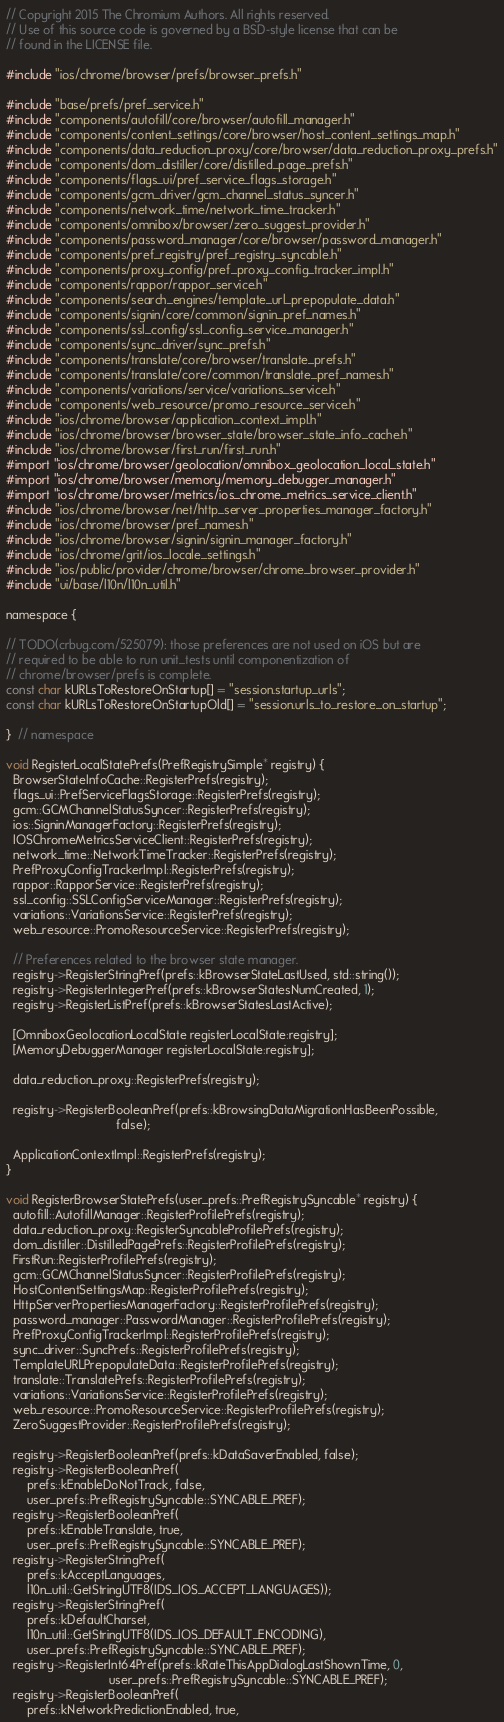Convert code to text. <code><loc_0><loc_0><loc_500><loc_500><_ObjectiveC_>// Copyright 2015 The Chromium Authors. All rights reserved.
// Use of this source code is governed by a BSD-style license that can be
// found in the LICENSE file.

#include "ios/chrome/browser/prefs/browser_prefs.h"

#include "base/prefs/pref_service.h"
#include "components/autofill/core/browser/autofill_manager.h"
#include "components/content_settings/core/browser/host_content_settings_map.h"
#include "components/data_reduction_proxy/core/browser/data_reduction_proxy_prefs.h"
#include "components/dom_distiller/core/distilled_page_prefs.h"
#include "components/flags_ui/pref_service_flags_storage.h"
#include "components/gcm_driver/gcm_channel_status_syncer.h"
#include "components/network_time/network_time_tracker.h"
#include "components/omnibox/browser/zero_suggest_provider.h"
#include "components/password_manager/core/browser/password_manager.h"
#include "components/pref_registry/pref_registry_syncable.h"
#include "components/proxy_config/pref_proxy_config_tracker_impl.h"
#include "components/rappor/rappor_service.h"
#include "components/search_engines/template_url_prepopulate_data.h"
#include "components/signin/core/common/signin_pref_names.h"
#include "components/ssl_config/ssl_config_service_manager.h"
#include "components/sync_driver/sync_prefs.h"
#include "components/translate/core/browser/translate_prefs.h"
#include "components/translate/core/common/translate_pref_names.h"
#include "components/variations/service/variations_service.h"
#include "components/web_resource/promo_resource_service.h"
#include "ios/chrome/browser/application_context_impl.h"
#include "ios/chrome/browser/browser_state/browser_state_info_cache.h"
#include "ios/chrome/browser/first_run/first_run.h"
#import "ios/chrome/browser/geolocation/omnibox_geolocation_local_state.h"
#import "ios/chrome/browser/memory/memory_debugger_manager.h"
#import "ios/chrome/browser/metrics/ios_chrome_metrics_service_client.h"
#include "ios/chrome/browser/net/http_server_properties_manager_factory.h"
#include "ios/chrome/browser/pref_names.h"
#include "ios/chrome/browser/signin/signin_manager_factory.h"
#include "ios/chrome/grit/ios_locale_settings.h"
#include "ios/public/provider/chrome/browser/chrome_browser_provider.h"
#include "ui/base/l10n/l10n_util.h"

namespace {

// TODO(crbug.com/525079): those preferences are not used on iOS but are
// required to be able to run unit_tests until componentization of
// chrome/browser/prefs is complete.
const char kURLsToRestoreOnStartup[] = "session.startup_urls";
const char kURLsToRestoreOnStartupOld[] = "session.urls_to_restore_on_startup";

}  // namespace

void RegisterLocalStatePrefs(PrefRegistrySimple* registry) {
  BrowserStateInfoCache::RegisterPrefs(registry);
  flags_ui::PrefServiceFlagsStorage::RegisterPrefs(registry);
  gcm::GCMChannelStatusSyncer::RegisterPrefs(registry);
  ios::SigninManagerFactory::RegisterPrefs(registry);
  IOSChromeMetricsServiceClient::RegisterPrefs(registry);
  network_time::NetworkTimeTracker::RegisterPrefs(registry);
  PrefProxyConfigTrackerImpl::RegisterPrefs(registry);
  rappor::RapporService::RegisterPrefs(registry);
  ssl_config::SSLConfigServiceManager::RegisterPrefs(registry);
  variations::VariationsService::RegisterPrefs(registry);
  web_resource::PromoResourceService::RegisterPrefs(registry);

  // Preferences related to the browser state manager.
  registry->RegisterStringPref(prefs::kBrowserStateLastUsed, std::string());
  registry->RegisterIntegerPref(prefs::kBrowserStatesNumCreated, 1);
  registry->RegisterListPref(prefs::kBrowserStatesLastActive);

  [OmniboxGeolocationLocalState registerLocalState:registry];
  [MemoryDebuggerManager registerLocalState:registry];

  data_reduction_proxy::RegisterPrefs(registry);

  registry->RegisterBooleanPref(prefs::kBrowsingDataMigrationHasBeenPossible,
                                false);

  ApplicationContextImpl::RegisterPrefs(registry);
}

void RegisterBrowserStatePrefs(user_prefs::PrefRegistrySyncable* registry) {
  autofill::AutofillManager::RegisterProfilePrefs(registry);
  data_reduction_proxy::RegisterSyncableProfilePrefs(registry);
  dom_distiller::DistilledPagePrefs::RegisterProfilePrefs(registry);
  FirstRun::RegisterProfilePrefs(registry);
  gcm::GCMChannelStatusSyncer::RegisterProfilePrefs(registry);
  HostContentSettingsMap::RegisterProfilePrefs(registry);
  HttpServerPropertiesManagerFactory::RegisterProfilePrefs(registry);
  password_manager::PasswordManager::RegisterProfilePrefs(registry);
  PrefProxyConfigTrackerImpl::RegisterProfilePrefs(registry);
  sync_driver::SyncPrefs::RegisterProfilePrefs(registry);
  TemplateURLPrepopulateData::RegisterProfilePrefs(registry);
  translate::TranslatePrefs::RegisterProfilePrefs(registry);
  variations::VariationsService::RegisterProfilePrefs(registry);
  web_resource::PromoResourceService::RegisterProfilePrefs(registry);
  ZeroSuggestProvider::RegisterProfilePrefs(registry);

  registry->RegisterBooleanPref(prefs::kDataSaverEnabled, false);
  registry->RegisterBooleanPref(
      prefs::kEnableDoNotTrack, false,
      user_prefs::PrefRegistrySyncable::SYNCABLE_PREF);
  registry->RegisterBooleanPref(
      prefs::kEnableTranslate, true,
      user_prefs::PrefRegistrySyncable::SYNCABLE_PREF);
  registry->RegisterStringPref(
      prefs::kAcceptLanguages,
      l10n_util::GetStringUTF8(IDS_IOS_ACCEPT_LANGUAGES));
  registry->RegisterStringPref(
      prefs::kDefaultCharset,
      l10n_util::GetStringUTF8(IDS_IOS_DEFAULT_ENCODING),
      user_prefs::PrefRegistrySyncable::SYNCABLE_PREF);
  registry->RegisterInt64Pref(prefs::kRateThisAppDialogLastShownTime, 0,
                              user_prefs::PrefRegistrySyncable::SYNCABLE_PREF);
  registry->RegisterBooleanPref(
      prefs::kNetworkPredictionEnabled, true,</code> 